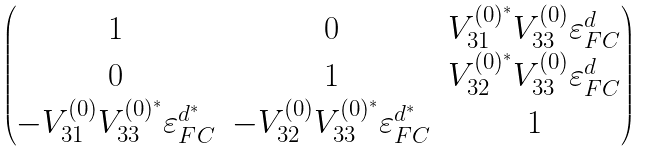<formula> <loc_0><loc_0><loc_500><loc_500>\begin{pmatrix} 1 & 0 & V _ { 3 1 } ^ { ( 0 ) ^ { * } } V _ { 3 3 } ^ { ( 0 ) } \varepsilon _ { F C } ^ { d } \\ 0 & 1 & V _ { 3 2 } ^ { ( 0 ) ^ { * } } V _ { 3 3 } ^ { ( 0 ) } \varepsilon _ { F C } ^ { d } \\ - V _ { 3 1 } ^ { ( 0 ) } V _ { 3 3 } ^ { ( 0 ) ^ { * } } \varepsilon _ { F C } ^ { d ^ { * } } & - V _ { 3 2 } ^ { ( 0 ) } V _ { 3 3 } ^ { ( 0 ) ^ { * } } \varepsilon _ { F C } ^ { d ^ { * } } & 1 \end{pmatrix}</formula> 